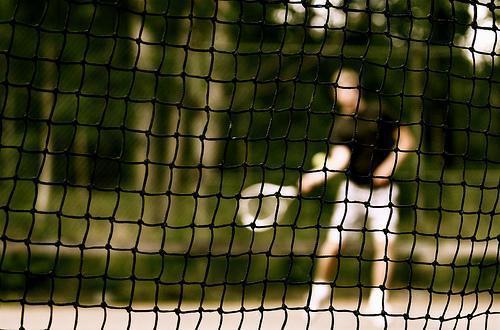How many people are in the picture?
Give a very brief answer. 1. 